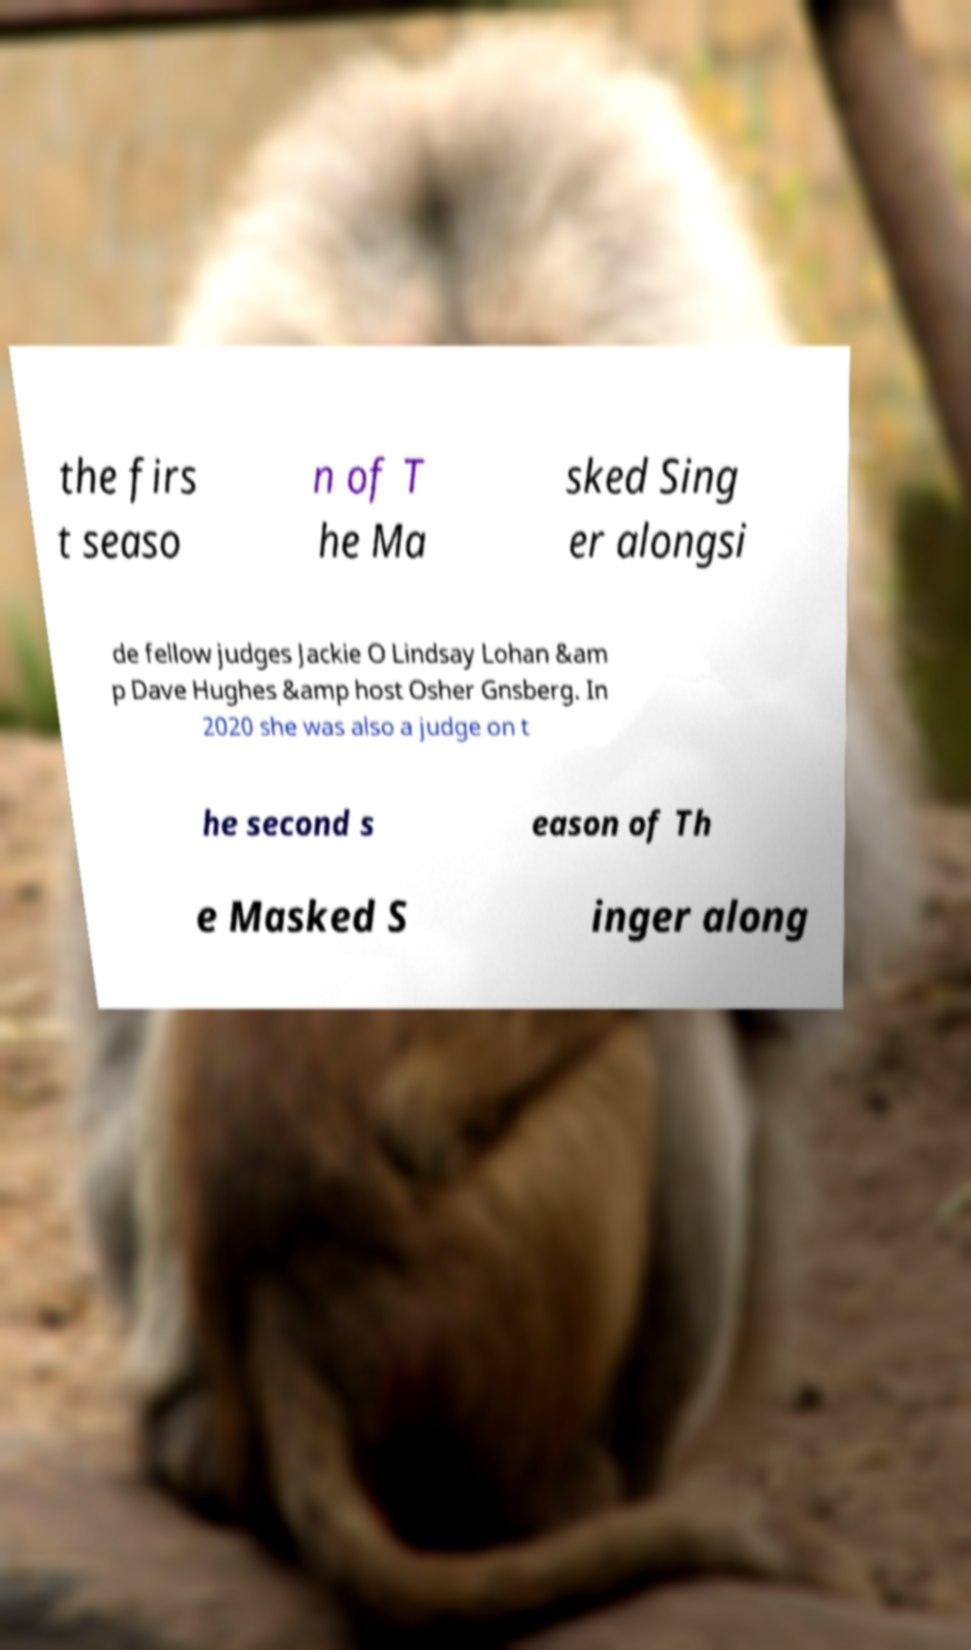Could you assist in decoding the text presented in this image and type it out clearly? the firs t seaso n of T he Ma sked Sing er alongsi de fellow judges Jackie O Lindsay Lohan &am p Dave Hughes &amp host Osher Gnsberg. In 2020 she was also a judge on t he second s eason of Th e Masked S inger along 